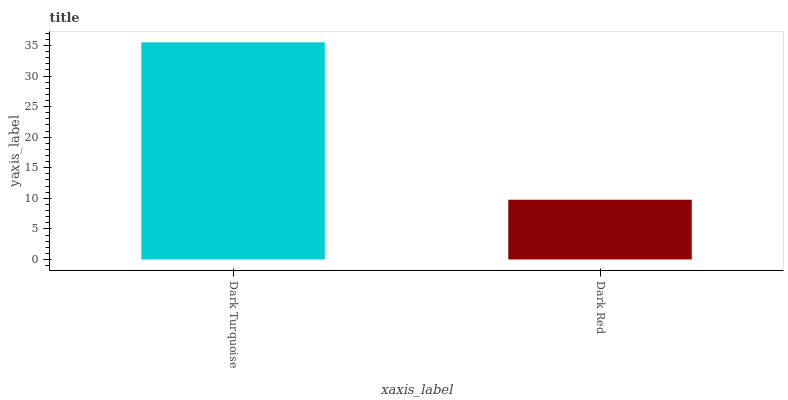Is Dark Red the maximum?
Answer yes or no. No. Is Dark Turquoise greater than Dark Red?
Answer yes or no. Yes. Is Dark Red less than Dark Turquoise?
Answer yes or no. Yes. Is Dark Red greater than Dark Turquoise?
Answer yes or no. No. Is Dark Turquoise less than Dark Red?
Answer yes or no. No. Is Dark Turquoise the high median?
Answer yes or no. Yes. Is Dark Red the low median?
Answer yes or no. Yes. Is Dark Red the high median?
Answer yes or no. No. Is Dark Turquoise the low median?
Answer yes or no. No. 